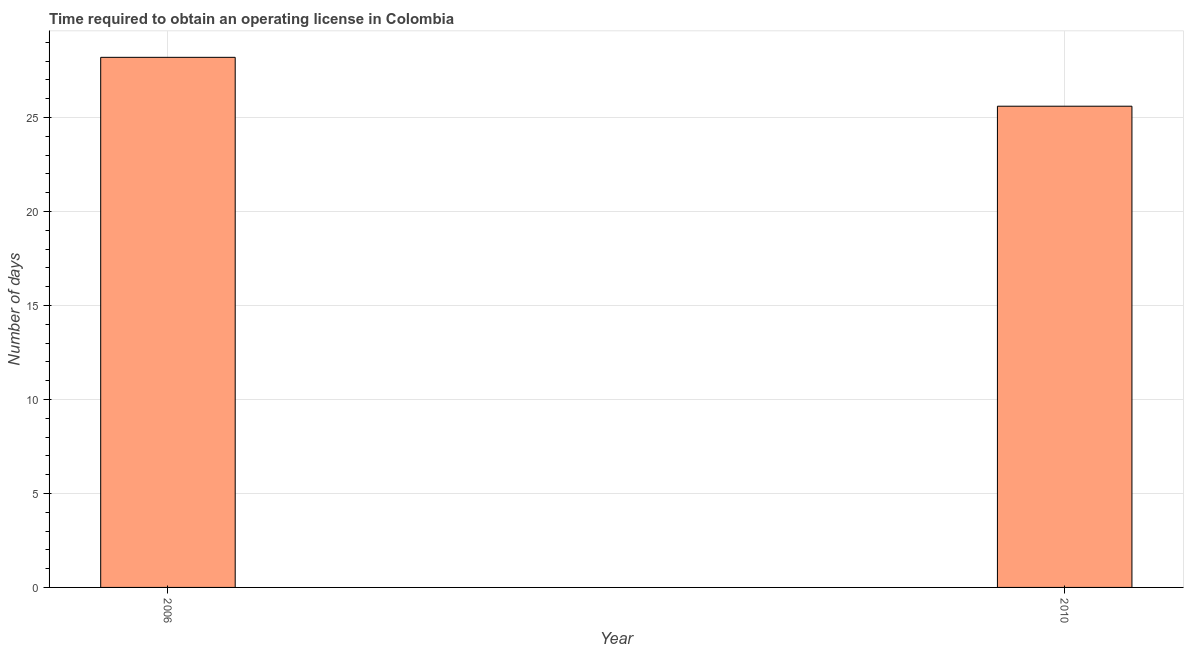Does the graph contain any zero values?
Ensure brevity in your answer.  No. What is the title of the graph?
Make the answer very short. Time required to obtain an operating license in Colombia. What is the label or title of the X-axis?
Provide a succinct answer. Year. What is the label or title of the Y-axis?
Your answer should be very brief. Number of days. What is the number of days to obtain operating license in 2010?
Your response must be concise. 25.6. Across all years, what is the maximum number of days to obtain operating license?
Offer a terse response. 28.2. Across all years, what is the minimum number of days to obtain operating license?
Offer a very short reply. 25.6. In which year was the number of days to obtain operating license maximum?
Offer a terse response. 2006. In which year was the number of days to obtain operating license minimum?
Ensure brevity in your answer.  2010. What is the sum of the number of days to obtain operating license?
Make the answer very short. 53.8. What is the difference between the number of days to obtain operating license in 2006 and 2010?
Your answer should be compact. 2.6. What is the average number of days to obtain operating license per year?
Provide a short and direct response. 26.9. What is the median number of days to obtain operating license?
Your answer should be very brief. 26.9. In how many years, is the number of days to obtain operating license greater than 11 days?
Make the answer very short. 2. What is the ratio of the number of days to obtain operating license in 2006 to that in 2010?
Provide a short and direct response. 1.1. In how many years, is the number of days to obtain operating license greater than the average number of days to obtain operating license taken over all years?
Your answer should be very brief. 1. How many bars are there?
Provide a short and direct response. 2. How many years are there in the graph?
Make the answer very short. 2. What is the difference between two consecutive major ticks on the Y-axis?
Offer a terse response. 5. Are the values on the major ticks of Y-axis written in scientific E-notation?
Provide a succinct answer. No. What is the Number of days of 2006?
Your answer should be very brief. 28.2. What is the Number of days of 2010?
Give a very brief answer. 25.6. What is the ratio of the Number of days in 2006 to that in 2010?
Offer a very short reply. 1.1. 